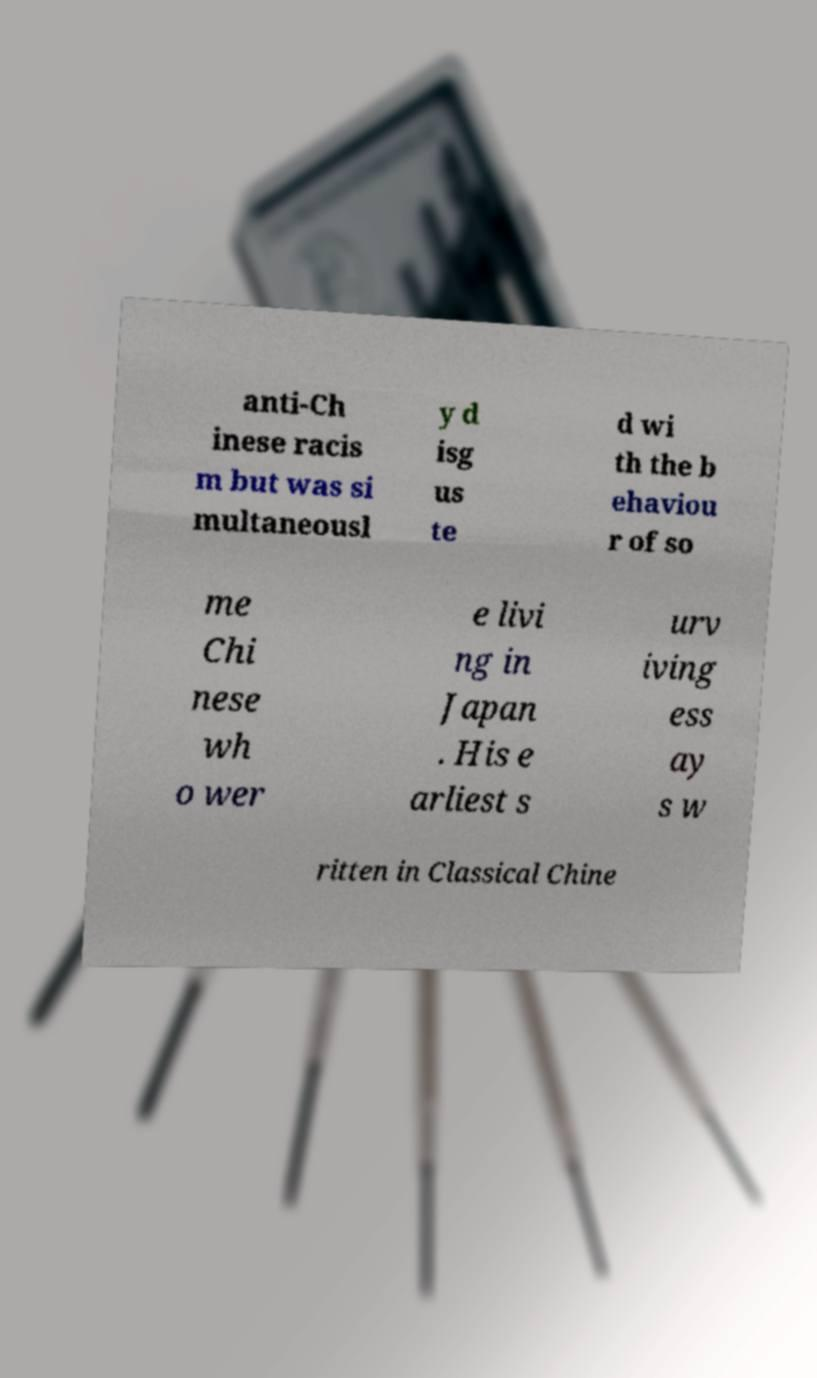Please read and relay the text visible in this image. What does it say? anti-Ch inese racis m but was si multaneousl y d isg us te d wi th the b ehaviou r of so me Chi nese wh o wer e livi ng in Japan . His e arliest s urv iving ess ay s w ritten in Classical Chine 